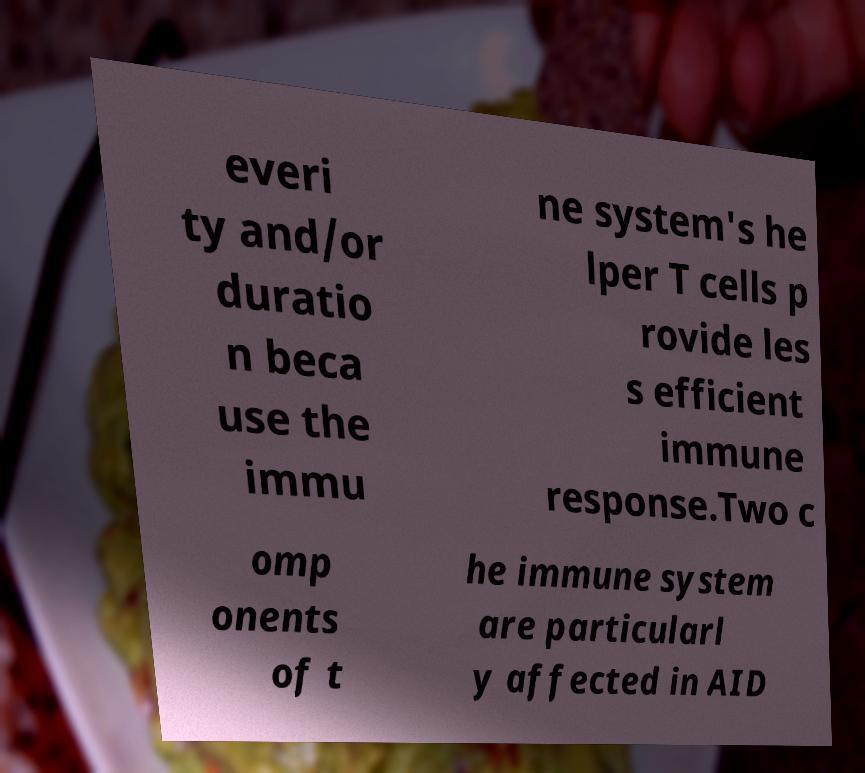Can you accurately transcribe the text from the provided image for me? everi ty and/or duratio n beca use the immu ne system's he lper T cells p rovide les s efficient immune response.Two c omp onents of t he immune system are particularl y affected in AID 